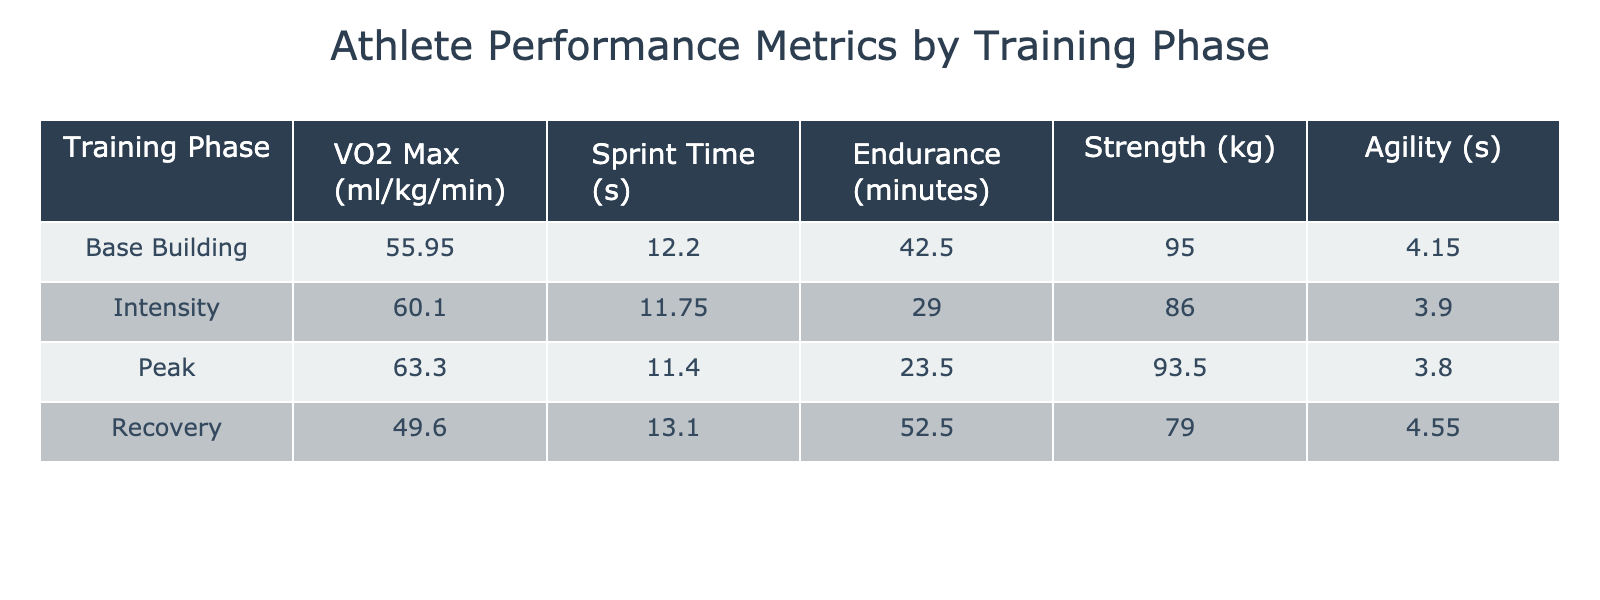What is the average VO2 Max for athletes in the Intensity phase? The VO2 Max values for athletes in the Intensity phase are 59.2 and 61.0. To find the average, add the two values (59.2 + 61.0 = 120.2) and divide by the number of athletes in that phase (2). Thus, the average is 120.2 / 2 = 60.1.
Answer: 60.1 Which athlete has the highest Endurance time? The Endurance times listed are 45, 30, 25, 50, 40, 28, 22, and 55 minutes. The highest value among these is 55 minutes, attributed to Lisa Chen in the Recovery phase.
Answer: Lisa Chen Is the Strength of athletes in the Peak phase higher than that of athletes in the Recovery phase? The Strength values for the Peak phase are 95 and 92 kg, averaging (95 + 92) / 2 = 93.5 kg. For the Recovery phase, the Strength values are 80 and 78 kg, averaging (80 + 78) / 2 = 79 kg. Since 93.5 kg is greater than 79 kg, the statement is true.
Answer: Yes What is the difference between the average Sprint Time in the Base Building phase and the Peak phase? The Sprint Times for Base Building are 12.3 and 12.1 seconds, averaging (12.3 + 12.1) / 2 = 12.2 seconds. For the Peak phase, the Times are 11.5 and 11.3 seconds, averaging (11.5 + 11.3) / 2 = 11.4 seconds. The difference is 12.2 - 11.4 = 0.8 seconds.
Answer: 0.8 seconds Which training phase has the best Agility average? The Agility times are 4.2, 4.0, 3.9, 4.5, 4.1, 3.8, 3.7, and 4.6 seconds, grouped by training phase as follows: Base Building (4.2, 4.1), Intensity (4.0, 3.8), Peak (3.9, 3.7), Recovery (4.5, 4.6). The averages are Base Building: (4.2 + 4.1) / 2 = 4.15 seconds, Intensity: (4.0 + 3.8) / 2 = 3.9 seconds, Peak: (3.9 + 3.7) / 2 = 3.8 seconds, Recovery: (4.5 + 4.6) / 2 = 4.55 seconds. Recovery has the highest average at 4.55 seconds.
Answer: Recovery Is it true that all athletes in the Peak phase have at least 60 VO2 Max? The VO2 Max values for athletes in the Peak phase are 62.1 and 64.5. Both values are greater than 60. Therefore, the statement is true.
Answer: Yes 